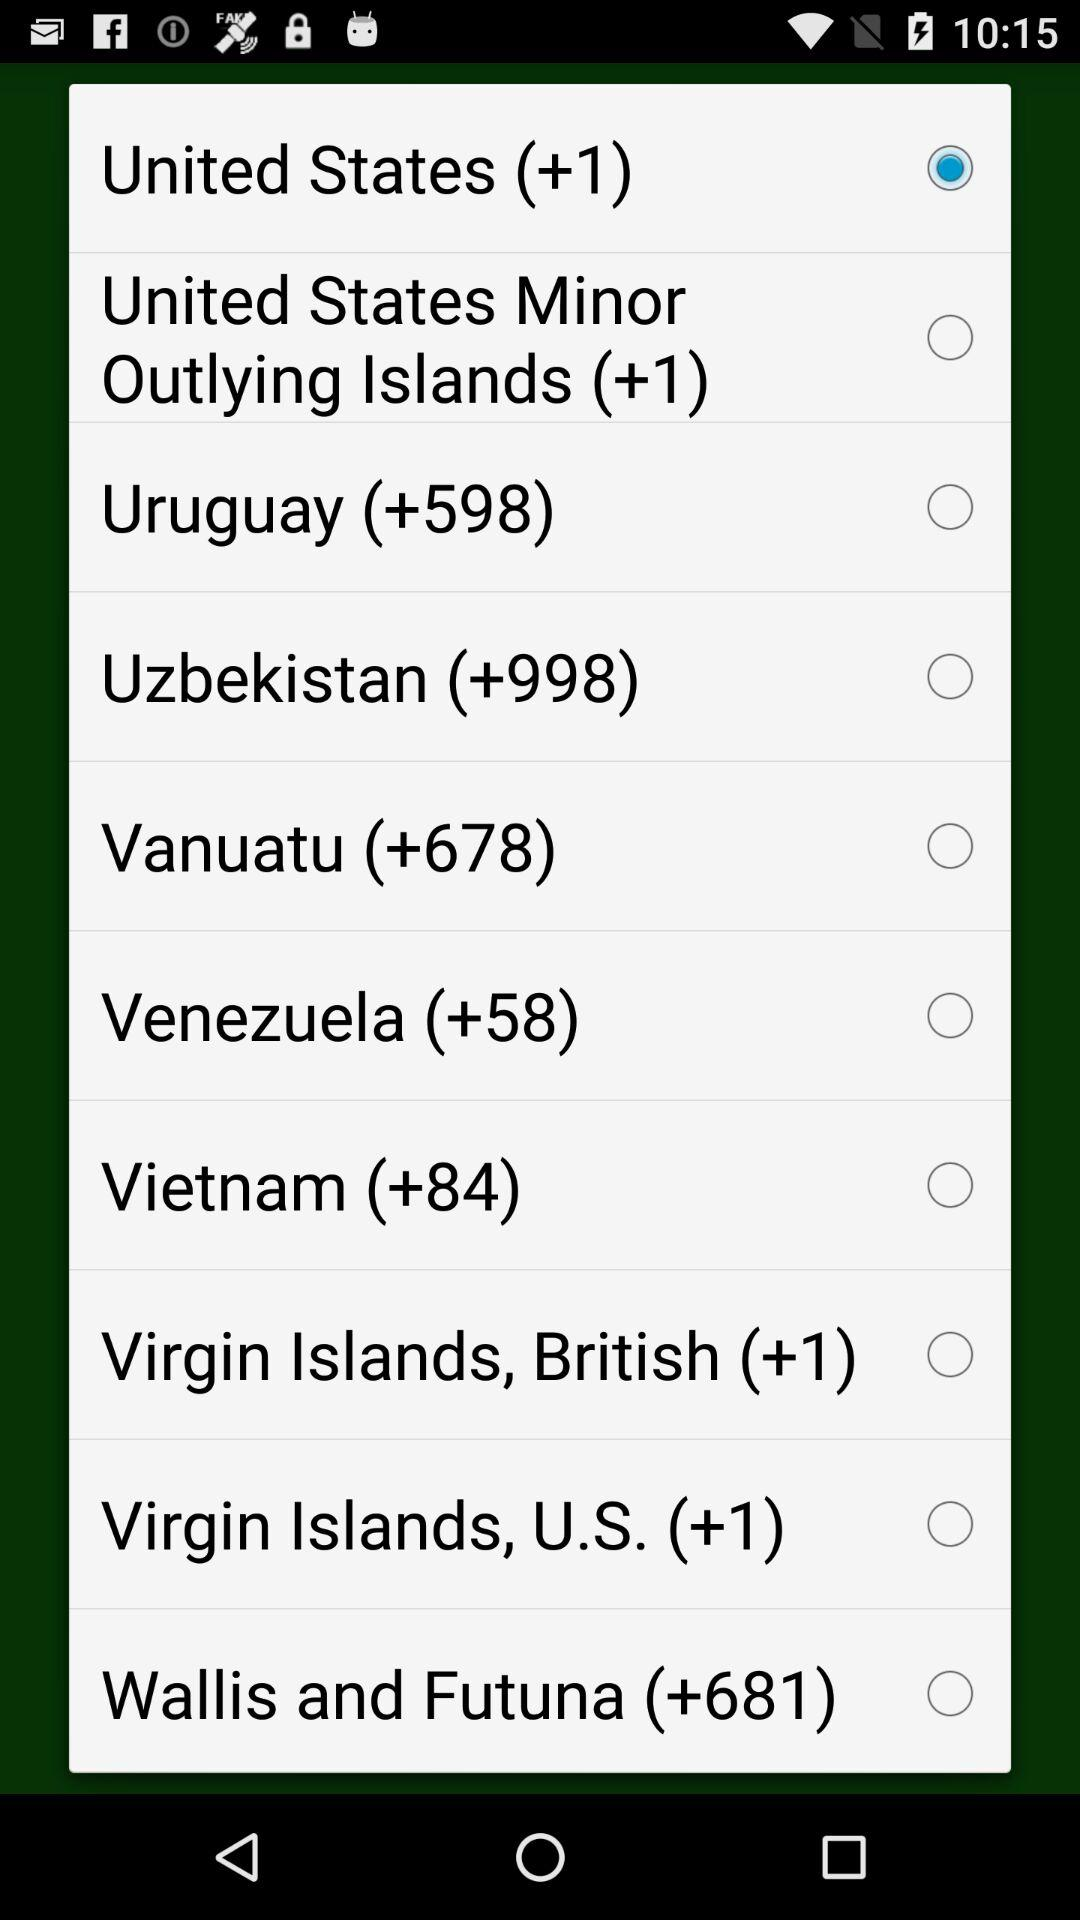What is the code of Uruguay? The code of Uruguay is +598. 